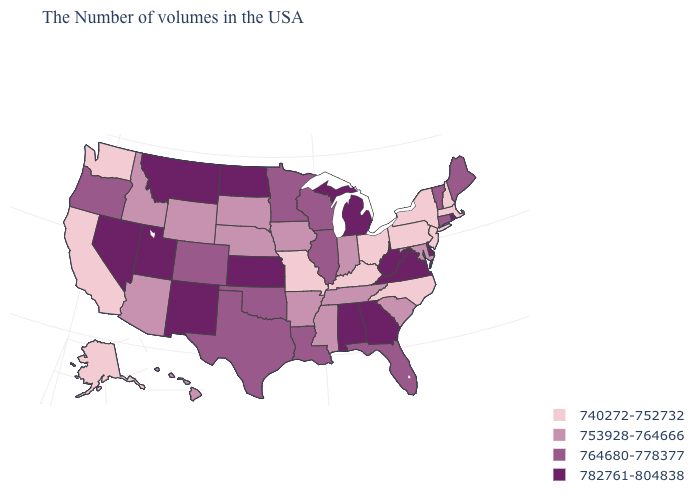Does Connecticut have the same value as Oregon?
Short answer required. Yes. What is the value of Minnesota?
Keep it brief. 764680-778377. Name the states that have a value in the range 764680-778377?
Quick response, please. Maine, Vermont, Connecticut, Florida, Wisconsin, Illinois, Louisiana, Minnesota, Oklahoma, Texas, Colorado, Oregon. What is the value of Arkansas?
Short answer required. 753928-764666. How many symbols are there in the legend?
Answer briefly. 4. Among the states that border Tennessee , which have the highest value?
Give a very brief answer. Virginia, Georgia, Alabama. What is the value of Virginia?
Concise answer only. 782761-804838. Does North Carolina have the lowest value in the USA?
Concise answer only. Yes. Name the states that have a value in the range 764680-778377?
Write a very short answer. Maine, Vermont, Connecticut, Florida, Wisconsin, Illinois, Louisiana, Minnesota, Oklahoma, Texas, Colorado, Oregon. Name the states that have a value in the range 753928-764666?
Write a very short answer. Maryland, South Carolina, Indiana, Tennessee, Mississippi, Arkansas, Iowa, Nebraska, South Dakota, Wyoming, Arizona, Idaho, Hawaii. Does the first symbol in the legend represent the smallest category?
Concise answer only. Yes. What is the lowest value in the USA?
Quick response, please. 740272-752732. Among the states that border New Mexico , does Texas have the lowest value?
Write a very short answer. No. Name the states that have a value in the range 740272-752732?
Be succinct. Massachusetts, New Hampshire, New York, New Jersey, Pennsylvania, North Carolina, Ohio, Kentucky, Missouri, California, Washington, Alaska. Among the states that border Utah , does Wyoming have the highest value?
Concise answer only. No. 